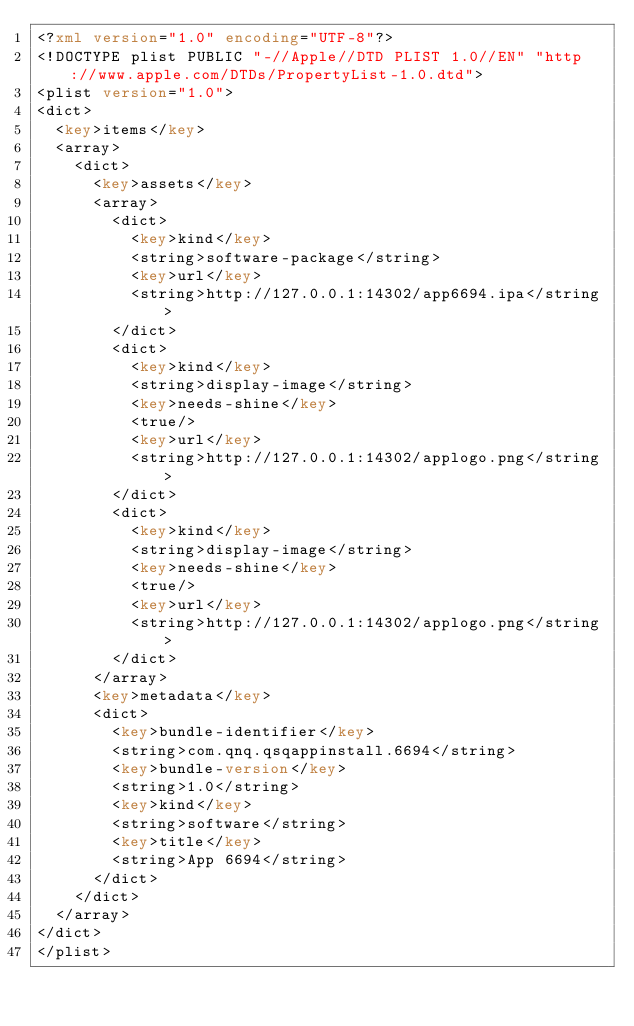Convert code to text. <code><loc_0><loc_0><loc_500><loc_500><_XML_><?xml version="1.0" encoding="UTF-8"?>
<!DOCTYPE plist PUBLIC "-//Apple//DTD PLIST 1.0//EN" "http://www.apple.com/DTDs/PropertyList-1.0.dtd">
<plist version="1.0">
<dict>
	<key>items</key>
	<array>
		<dict>
			<key>assets</key>
			<array>
				<dict>
					<key>kind</key>
					<string>software-package</string>
					<key>url</key>
					<string>http://127.0.0.1:14302/app6694.ipa</string>
				</dict>
				<dict>
					<key>kind</key>
					<string>display-image</string>
					<key>needs-shine</key>
					<true/>
					<key>url</key>
					<string>http://127.0.0.1:14302/applogo.png</string>
				</dict>
				<dict>
					<key>kind</key>
					<string>display-image</string>
					<key>needs-shine</key>
					<true/>
					<key>url</key>
					<string>http://127.0.0.1:14302/applogo.png</string>
				</dict>
			</array>
			<key>metadata</key>
			<dict>
				<key>bundle-identifier</key>
				<string>com.qnq.qsqappinstall.6694</string>
				<key>bundle-version</key>
				<string>1.0</string>
				<key>kind</key>
				<string>software</string>
				<key>title</key>
				<string>App 6694</string>
			</dict>
		</dict>
	</array>
</dict>
</plist>
</code> 